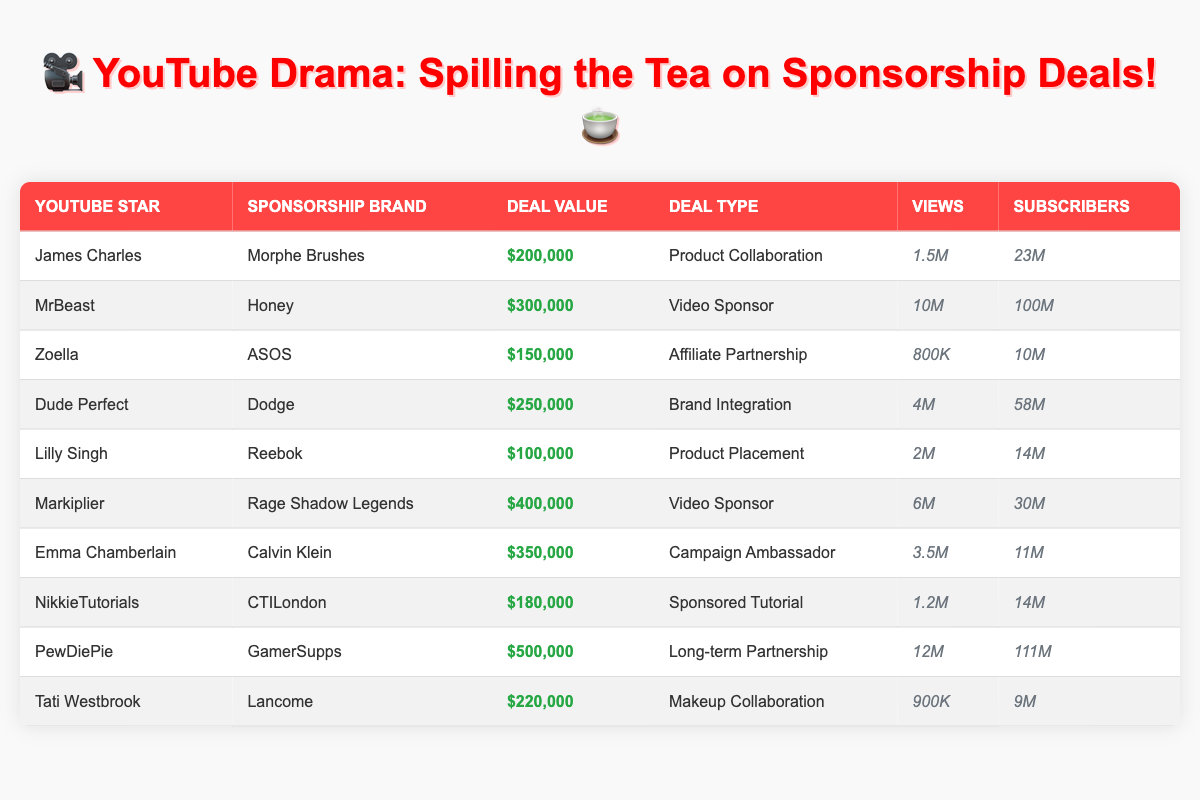What was the deal value for PewDiePie? The deal value is directly listed in the table under "Deal Value" for PewDiePie, which is $500,000.
Answer: $500,000 How many views did MrBeast's sponsorship deal generate? The number of views for MrBeast is found in the "Views" column of his entry, which shows 10 million views.
Answer: 10 million Who had the highest deal value, and what was it? Looking through the "Deal Value" column, PewDiePie has the highest value listed at $500,000.
Answer: PewDiePie, $500,000 What’s the total deal value for all sponsorships listed in the table? The deal values are $200,000 + $300,000 + $150,000 + $250,000 + $100,000 + $400,000 + $350,000 + $180,000 + $500,000 + $220,000, which sum up to $2,230,000.
Answer: $2,230,000 Did Emma Chamberlain have a sponsorship with a clothing brand? Emma Chamberlain partnered with Calvin Klein, which is a clothing brand, confirming that she had such a sponsorship.
Answer: Yes Which YouTube channel had the most subscribers in 2022? By checking the "Subscribers" column, PewDiePie has the highest count at 111 million subscribers compared to others.
Answer: PewDiePie, 111 million What is the average deal value across all sponsorships in the table? The total of all deal values (2,230,000) divided by the number of deals (10) results in an average deal value of $223,000.
Answer: $223,000 Which YouTube star partnered with ASOS and what was the deal value? The table shows that Zoella partnered with ASOS for a deal value of $150,000.
Answer: Zoella, $150,000 Is the deal type for Markiplier's sponsorship a product placement? Markiplier's deal type is listed as "Video Sponsor," not a product placement, making this statement false.
Answer: No 